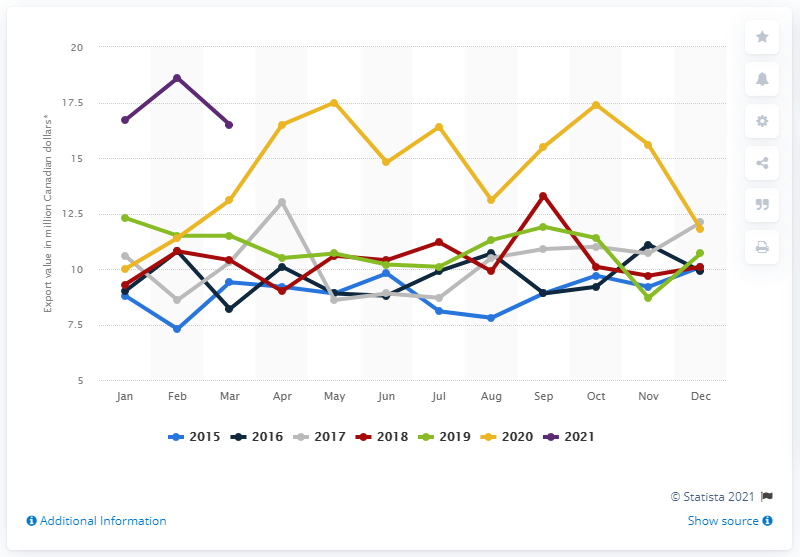Identify some key points in this picture. In March 2021, the value of exports of frozen, fresh, and canned fruit and vegetable juices from Canada amounted to CAD 16.4 million. 